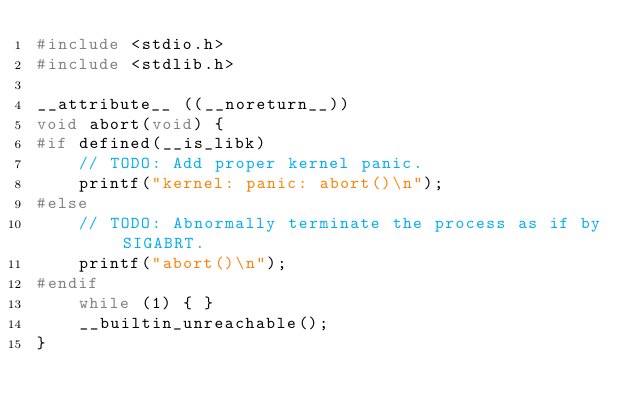<code> <loc_0><loc_0><loc_500><loc_500><_C_>#include <stdio.h>
#include <stdlib.h>

__attribute__ ((__noreturn__))
void abort(void) {
#if defined(__is_libk)
	// TODO: Add proper kernel panic.
	printf("kernel: panic: abort()\n");
#else
	// TODO: Abnormally terminate the process as if by SIGABRT.
	printf("abort()\n");
#endif
	while (1) { }
	__builtin_unreachable();
}
</code> 